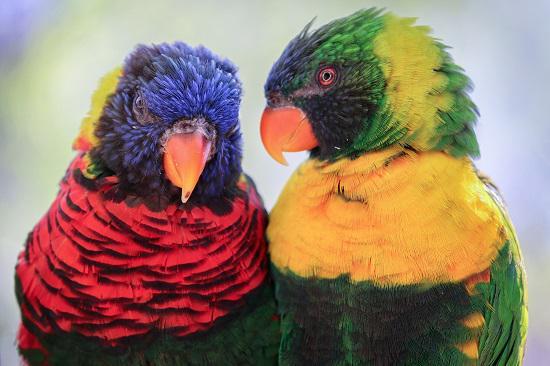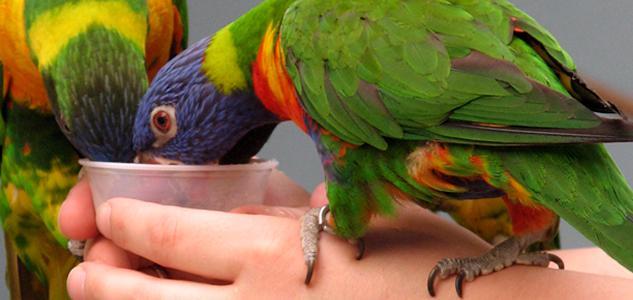The first image is the image on the left, the second image is the image on the right. Analyze the images presented: Is the assertion "There are three birds" valid? Answer yes or no. No. The first image is the image on the left, the second image is the image on the right. Given the left and right images, does the statement "There are three birds perched on something." hold true? Answer yes or no. No. 